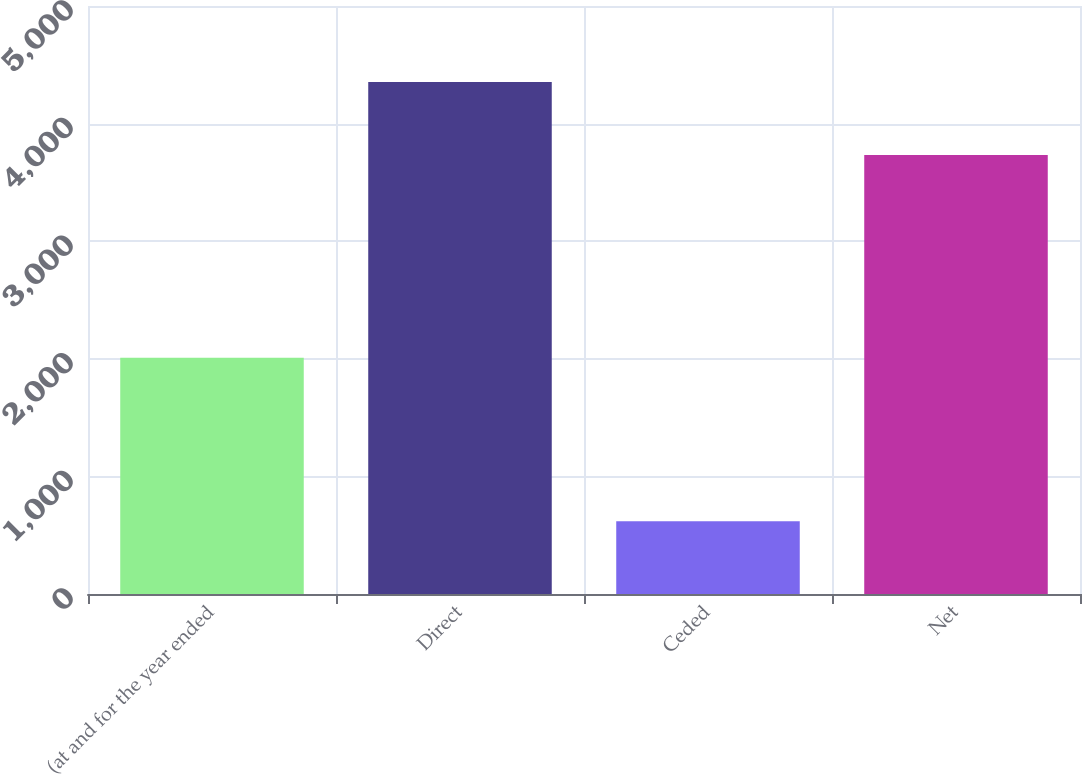Convert chart to OTSL. <chart><loc_0><loc_0><loc_500><loc_500><bar_chart><fcel>(at and for the year ended<fcel>Direct<fcel>Ceded<fcel>Net<nl><fcel>2008<fcel>4353<fcel>619<fcel>3734<nl></chart> 